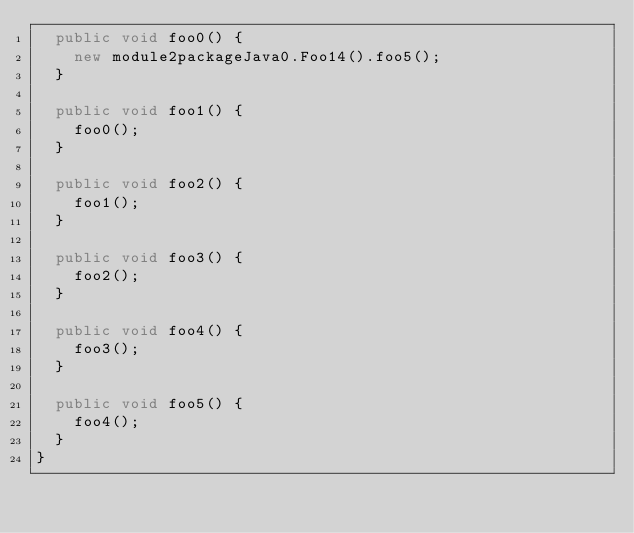<code> <loc_0><loc_0><loc_500><loc_500><_Java_>  public void foo0() {
    new module2packageJava0.Foo14().foo5();
  }

  public void foo1() {
    foo0();
  }

  public void foo2() {
    foo1();
  }

  public void foo3() {
    foo2();
  }

  public void foo4() {
    foo3();
  }

  public void foo5() {
    foo4();
  }
}
</code> 